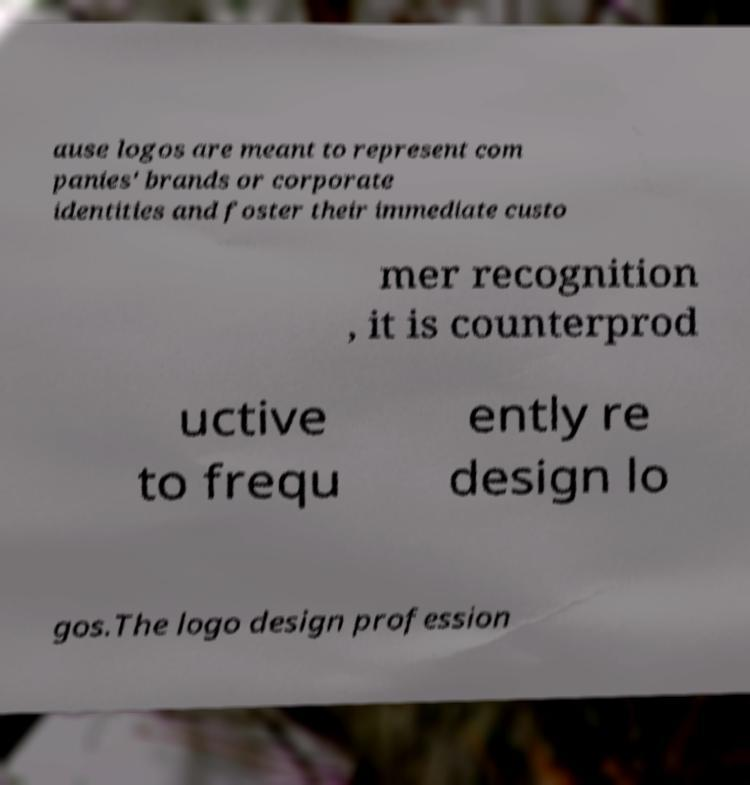Please identify and transcribe the text found in this image. ause logos are meant to represent com panies' brands or corporate identities and foster their immediate custo mer recognition , it is counterprod uctive to frequ ently re design lo gos.The logo design profession 